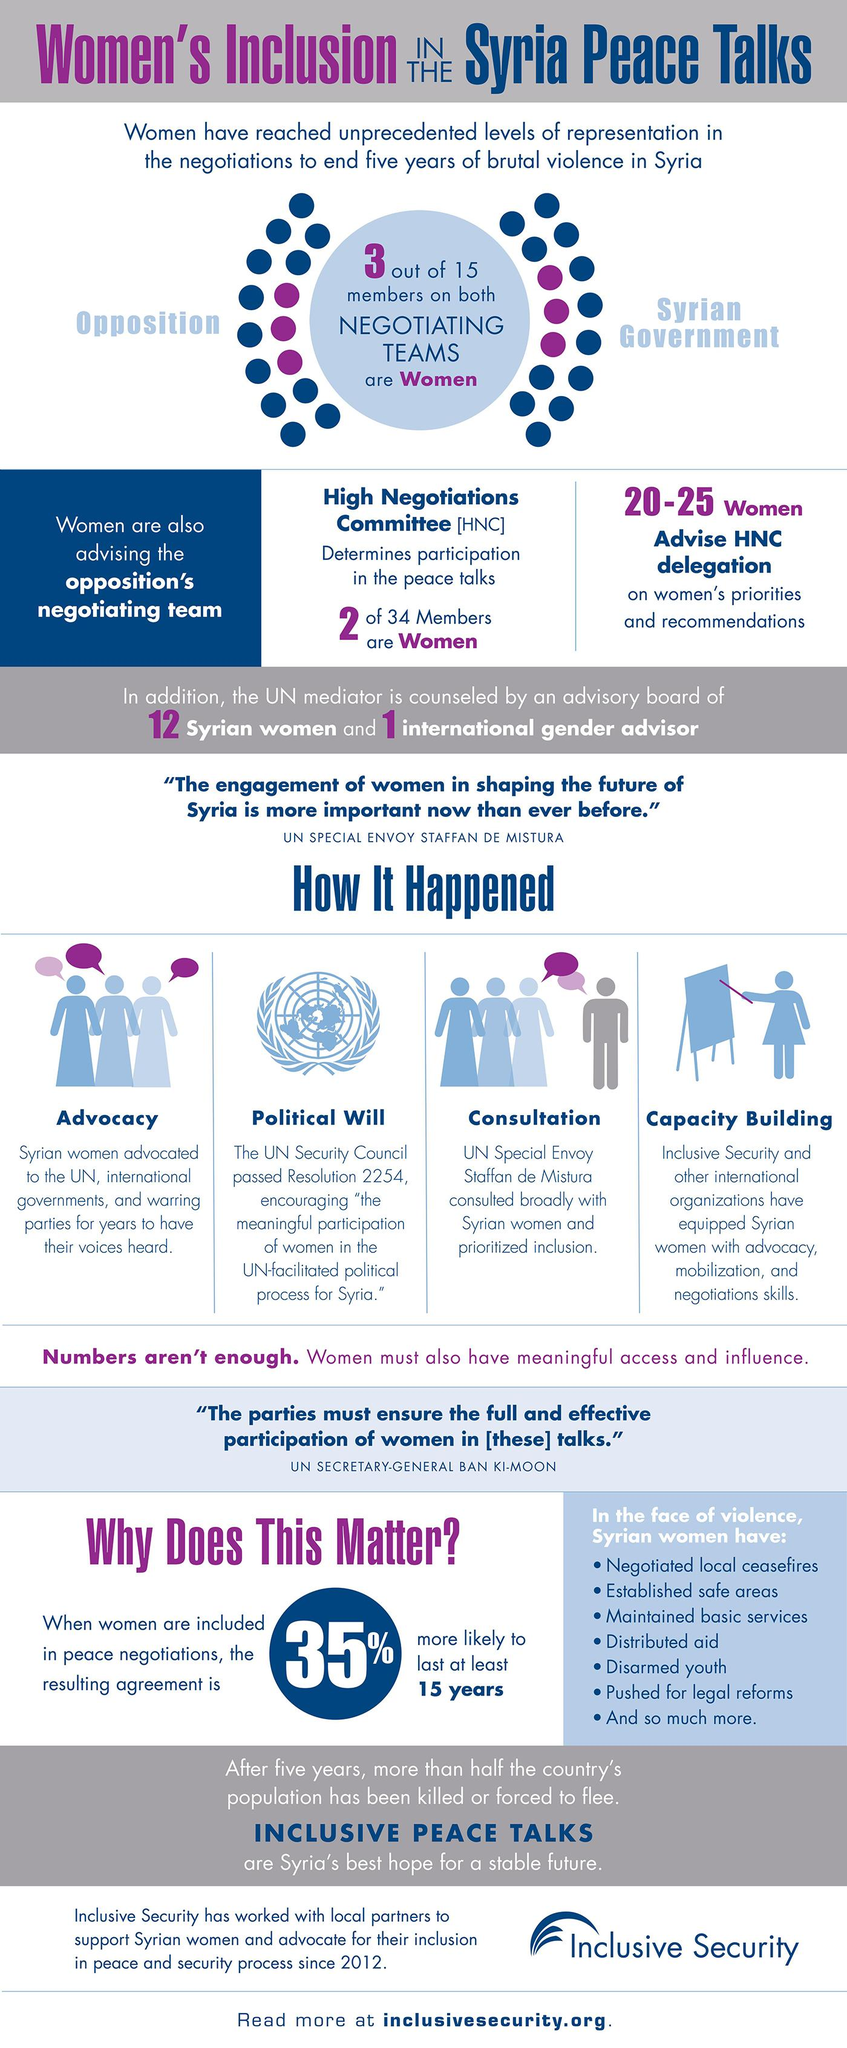Indicate a few pertinent items in this graphic. Seven actions have been taken by Syrian women in the face of violence. Out of the 30 members in the negotiating teams, only 6 of them are women. The Syrian peace talks involve negotiations between the opposition and the Syrian government. It is confirmed that the consultation with Syrian women was conducted by Staffan de Mistura, who prioritized their inclusion in the process. There are a total of 13 women and international general advisors on the advisory board. 